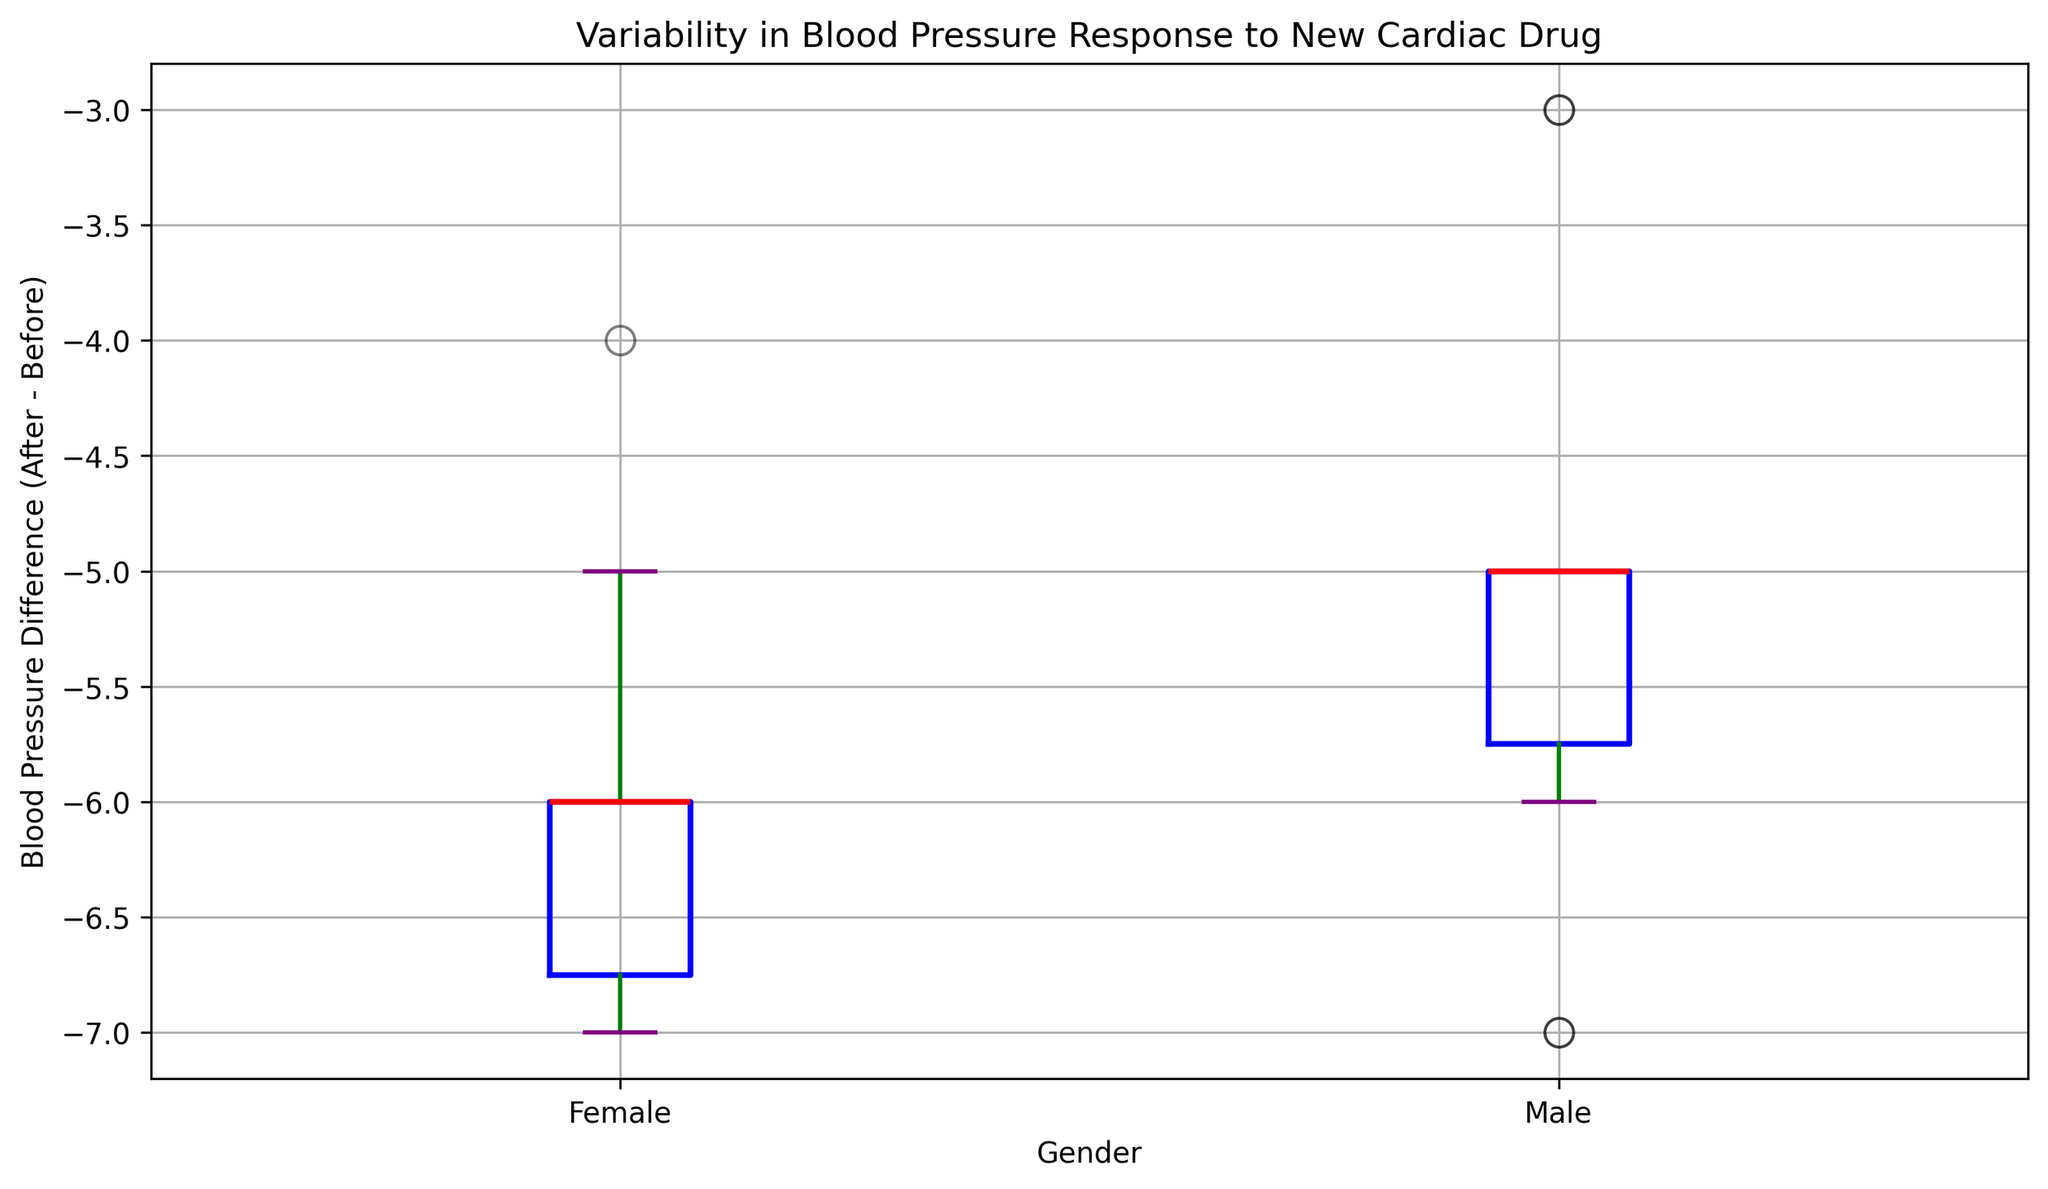What is the median blood pressure difference for males? From the boxplot, the median blood pressure difference is marked by the thick red line inside the male box.
Answer: -5 Is the variability in blood pressure difference larger for males or females? In a boxplot, variability can be seen by observing the size of the interquartile range (IQR), represented by the height of the box. The IQR is wider for males than females, indicating larger variability.
Answer: Males What are the lower and upper whiskers of the blood pressure difference for females? The whiskers represent the range of the data excluding outliers. From the boxplot, the lower whisker extends down to -5, and the upper whisker extends up to 0 for females.
Answer: Lower: -5, Upper: 0 Is there any indication of outliers in the data for either gender? Outliers in boxplots are indicated by individual points outside the whiskers. The plot shows no individual points outside the whiskers for both genders, indicating no outliers.
Answer: No How does the median blood pressure difference for males compare with that for females? The median value is indicated by the red line inside each box. The median for males is -5, and the median for females is -6, so the medial blood pressure difference for females is slightly lower than for males.
Answer: Females have a slightly lower median difference Which gender shows the least extreme in terms of maximum blood pressure difference? The maximum value is represented by the top whisker. For males, the top whisker is at -1, and for females, it is at 0, so males have a lower maximum difference.
Answer: Males What is the range of the blood pressure difference for males? The range is defined by the difference between the upper and lower whiskers. For males, the lower whisker is -8, and the upper whisker is -1. Therefore, the range is -1 - (-8) = 7.
Answer: 7 Do the males or females have a more consistent response to the cardiac drug? Consistency can be inferred by the tightness of the data spread shown by the height of the box (IQR). The box for females is shorter compared to the box for males, indicating that females have a more consistent response.
Answer: Females 